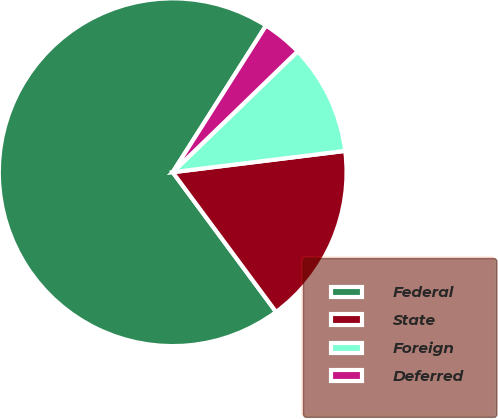Convert chart to OTSL. <chart><loc_0><loc_0><loc_500><loc_500><pie_chart><fcel>Federal<fcel>State<fcel>Foreign<fcel>Deferred<nl><fcel>69.16%<fcel>16.82%<fcel>10.28%<fcel>3.74%<nl></chart> 